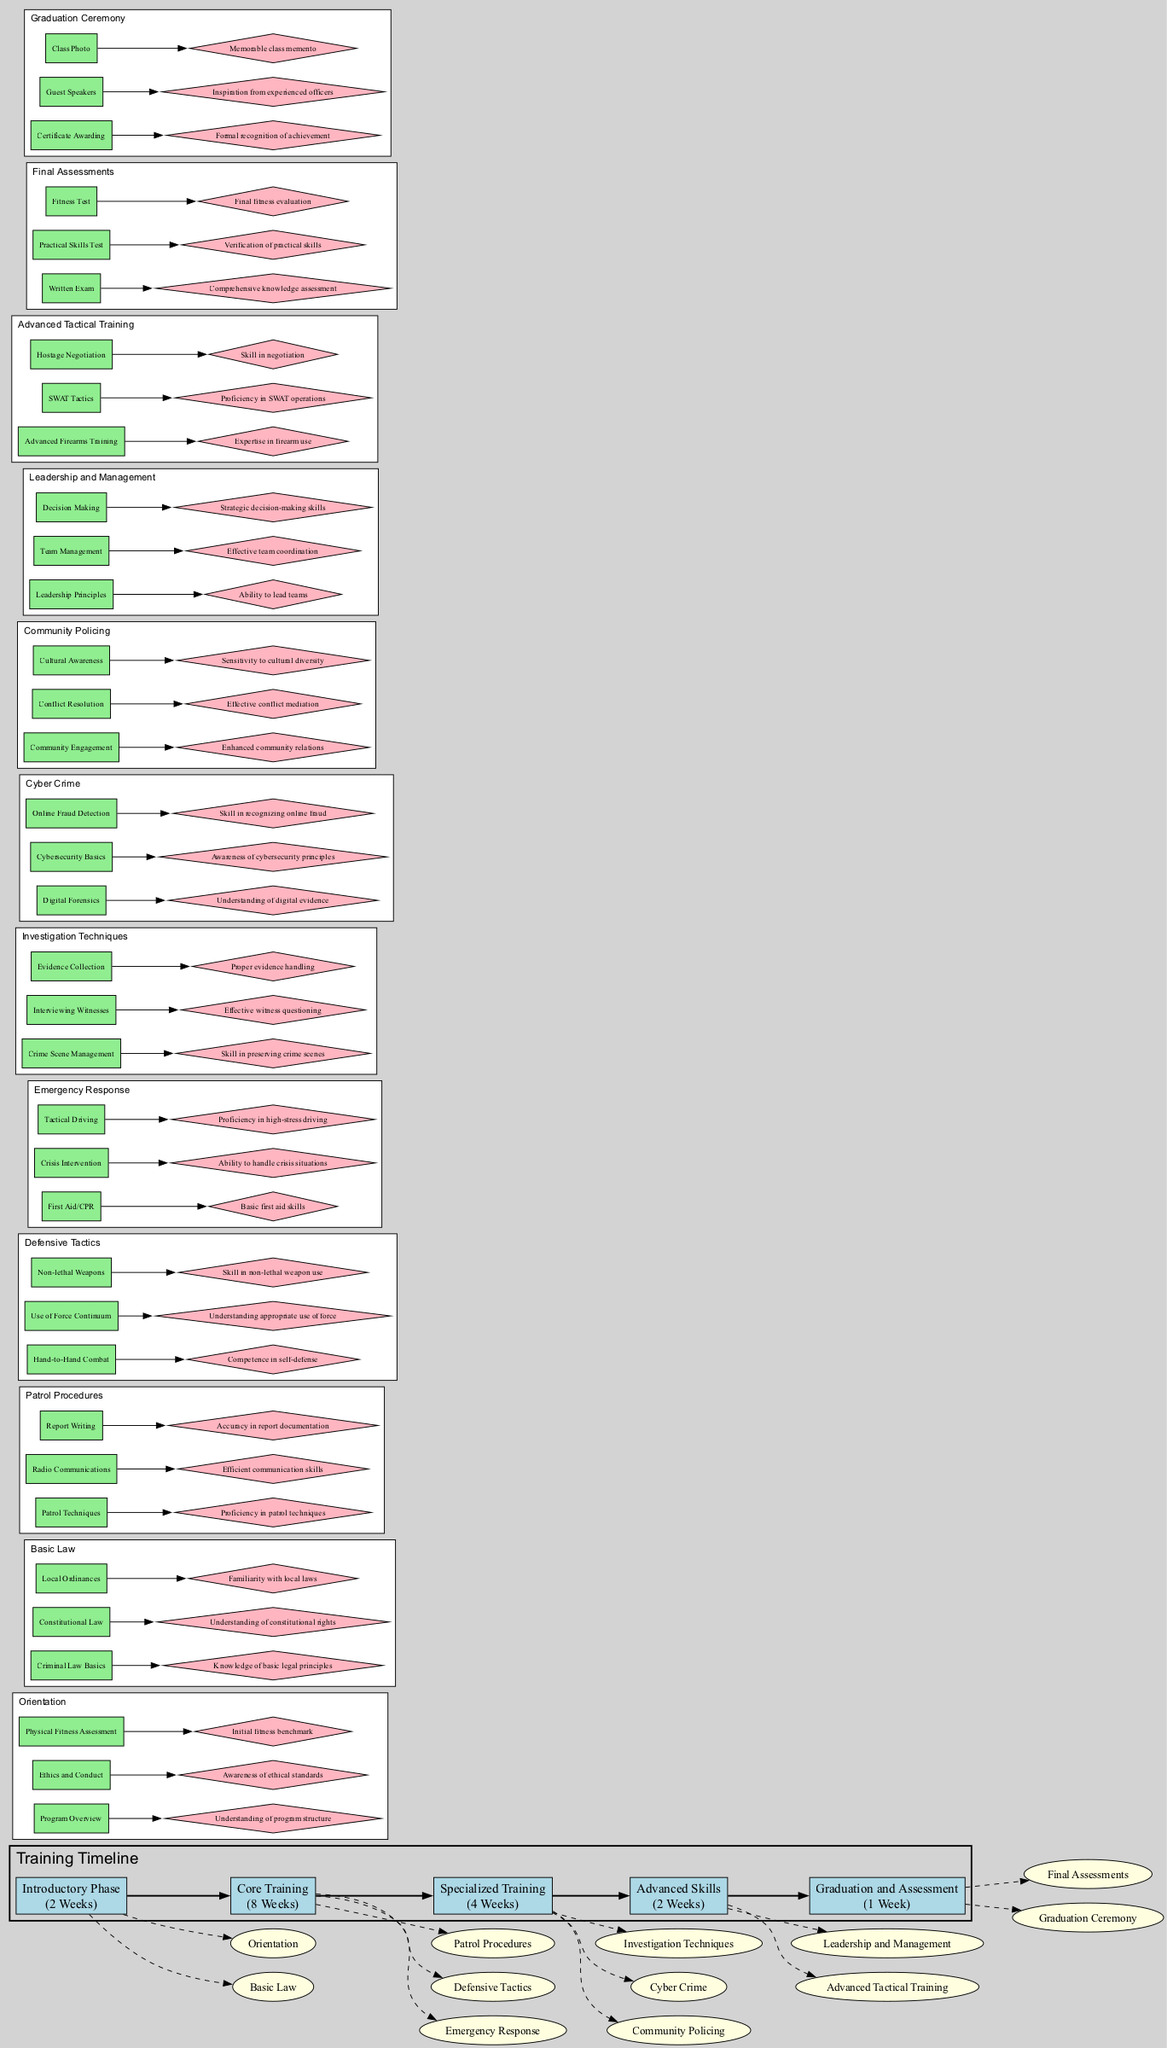What is the duration of the Core Training phase? The diagram indicates that the Core Training phase has a specified duration of 8 Weeks.
Answer: 8 Weeks How many modules are there in the Specialized Training phase? By examining the diagram, there are 3 modules listed under the Specialized Training phase: Investigation Techniques, Cyber Crime, and Community Policing.
Answer: 3 What is one component of the Defensive Tactics module? From the diagram, one listed component of the Defensive Tactics module is "Hand-to-Hand Combat."
Answer: Hand-to-Hand Combat Which module focuses on community engagement? The diagram shows that the module named "Community Policing" emphasizes community engagement as one of its key areas.
Answer: Community Policing What is the expected outcome of the Orientation module? According to the diagram, one of the expected outcomes of the Orientation module is "Understanding of program structure."
Answer: Understanding of program structure What type of training is provided in the Advanced Skills phase? The Advanced Skills phase provides training on Leadership and Management as well as Advanced Tactical Training, suggesting a focus on enhancing advanced skills.
Answer: Leadership and Management, Advanced Tactical Training How do the modules under the Core Training phase relate to the Introductory phase? The diagram outlines a flow where the Core Training modules follow the Introductory phase modules, suggesting that the Core training is built upon the foundational knowledge acquired in the Introductory phase.
Answer: Follow What is a common outcome shared by many modules across the diagram? Many modules include outcomes related to skills development, such as "Skill in non-lethal weapon use" and "Proficiency in patrol techniques," indicating a shared focus on practical skills.
Answer: Skills development What distinguishes the Graduation and Assessment phase from other phases? The Graduation and Assessment phase includes components aimed at evaluation, such as the "Written Exam" and "Practical Skills Test," which sets it apart from the training-focused phases.
Answer: Evaluation components 